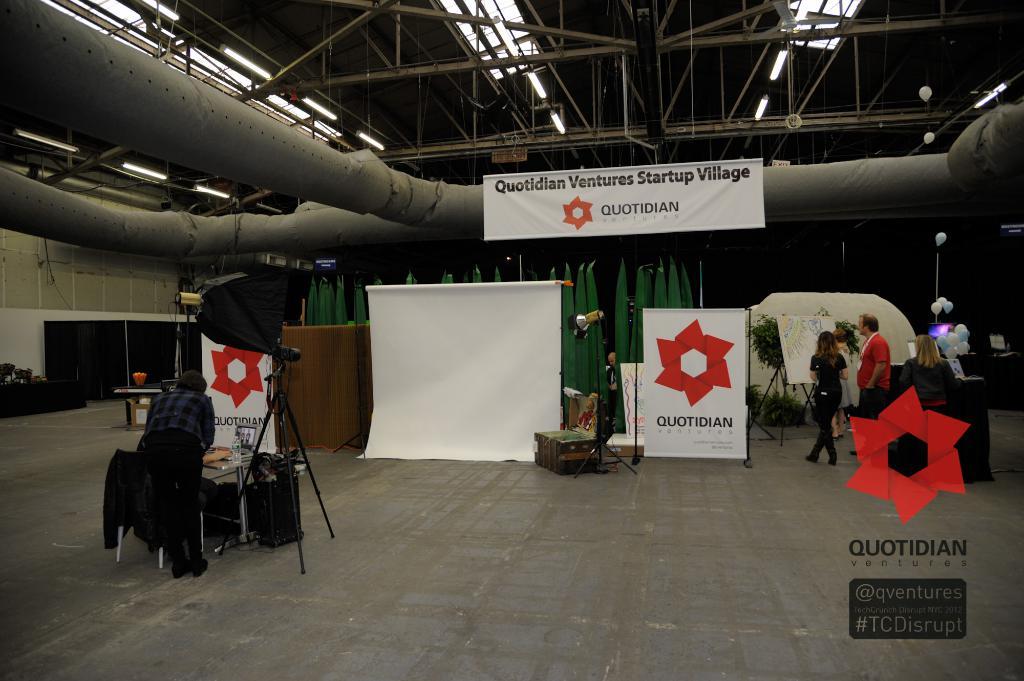What brand name is displayed multiple times in this photo?
Offer a very short reply. Quotidian. 